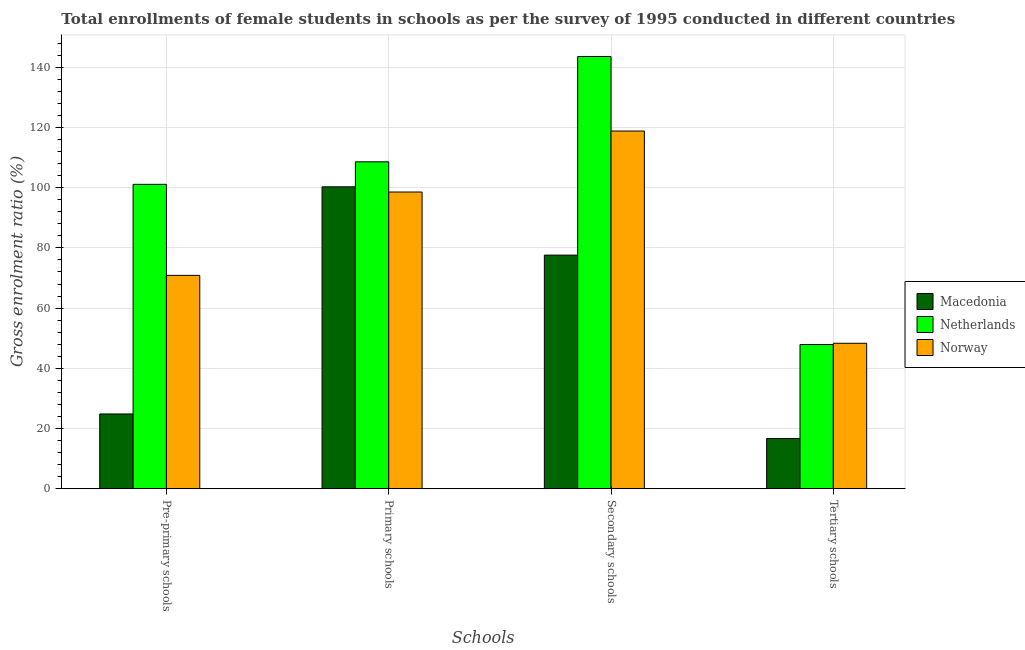How many different coloured bars are there?
Offer a very short reply. 3. How many bars are there on the 3rd tick from the left?
Your answer should be compact. 3. How many bars are there on the 2nd tick from the right?
Give a very brief answer. 3. What is the label of the 4th group of bars from the left?
Offer a very short reply. Tertiary schools. What is the gross enrolment ratio(female) in tertiary schools in Macedonia?
Provide a succinct answer. 16.67. Across all countries, what is the maximum gross enrolment ratio(female) in secondary schools?
Your response must be concise. 143.6. Across all countries, what is the minimum gross enrolment ratio(female) in secondary schools?
Provide a succinct answer. 77.61. In which country was the gross enrolment ratio(female) in tertiary schools minimum?
Make the answer very short. Macedonia. What is the total gross enrolment ratio(female) in pre-primary schools in the graph?
Your answer should be very brief. 196.81. What is the difference between the gross enrolment ratio(female) in tertiary schools in Netherlands and that in Norway?
Keep it short and to the point. -0.42. What is the difference between the gross enrolment ratio(female) in pre-primary schools in Macedonia and the gross enrolment ratio(female) in tertiary schools in Netherlands?
Provide a succinct answer. -23.07. What is the average gross enrolment ratio(female) in primary schools per country?
Provide a short and direct response. 102.49. What is the difference between the gross enrolment ratio(female) in secondary schools and gross enrolment ratio(female) in primary schools in Netherlands?
Provide a succinct answer. 35. What is the ratio of the gross enrolment ratio(female) in tertiary schools in Netherlands to that in Norway?
Provide a short and direct response. 0.99. What is the difference between the highest and the second highest gross enrolment ratio(female) in secondary schools?
Provide a short and direct response. 24.77. What is the difference between the highest and the lowest gross enrolment ratio(female) in pre-primary schools?
Provide a succinct answer. 76.3. Is it the case that in every country, the sum of the gross enrolment ratio(female) in pre-primary schools and gross enrolment ratio(female) in tertiary schools is greater than the sum of gross enrolment ratio(female) in secondary schools and gross enrolment ratio(female) in primary schools?
Provide a short and direct response. No. How many bars are there?
Give a very brief answer. 12. How many countries are there in the graph?
Ensure brevity in your answer.  3. Does the graph contain any zero values?
Your response must be concise. No. Does the graph contain grids?
Your answer should be very brief. Yes. What is the title of the graph?
Give a very brief answer. Total enrollments of female students in schools as per the survey of 1995 conducted in different countries. Does "Guinea-Bissau" appear as one of the legend labels in the graph?
Offer a terse response. No. What is the label or title of the X-axis?
Ensure brevity in your answer.  Schools. What is the Gross enrolment ratio (%) of Macedonia in Pre-primary schools?
Your answer should be very brief. 24.82. What is the Gross enrolment ratio (%) in Netherlands in Pre-primary schools?
Give a very brief answer. 101.12. What is the Gross enrolment ratio (%) in Norway in Pre-primary schools?
Your answer should be compact. 70.87. What is the Gross enrolment ratio (%) of Macedonia in Primary schools?
Keep it short and to the point. 100.29. What is the Gross enrolment ratio (%) in Netherlands in Primary schools?
Your answer should be very brief. 108.6. What is the Gross enrolment ratio (%) of Norway in Primary schools?
Offer a terse response. 98.57. What is the Gross enrolment ratio (%) of Macedonia in Secondary schools?
Keep it short and to the point. 77.61. What is the Gross enrolment ratio (%) of Netherlands in Secondary schools?
Your answer should be compact. 143.6. What is the Gross enrolment ratio (%) of Norway in Secondary schools?
Give a very brief answer. 118.83. What is the Gross enrolment ratio (%) in Macedonia in Tertiary schools?
Keep it short and to the point. 16.67. What is the Gross enrolment ratio (%) of Netherlands in Tertiary schools?
Ensure brevity in your answer.  47.89. What is the Gross enrolment ratio (%) of Norway in Tertiary schools?
Ensure brevity in your answer.  48.31. Across all Schools, what is the maximum Gross enrolment ratio (%) in Macedonia?
Give a very brief answer. 100.29. Across all Schools, what is the maximum Gross enrolment ratio (%) of Netherlands?
Make the answer very short. 143.6. Across all Schools, what is the maximum Gross enrolment ratio (%) in Norway?
Make the answer very short. 118.83. Across all Schools, what is the minimum Gross enrolment ratio (%) in Macedonia?
Offer a terse response. 16.67. Across all Schools, what is the minimum Gross enrolment ratio (%) of Netherlands?
Offer a very short reply. 47.89. Across all Schools, what is the minimum Gross enrolment ratio (%) of Norway?
Provide a succinct answer. 48.31. What is the total Gross enrolment ratio (%) in Macedonia in the graph?
Your answer should be compact. 219.39. What is the total Gross enrolment ratio (%) in Netherlands in the graph?
Keep it short and to the point. 401.21. What is the total Gross enrolment ratio (%) in Norway in the graph?
Give a very brief answer. 336.58. What is the difference between the Gross enrolment ratio (%) in Macedonia in Pre-primary schools and that in Primary schools?
Offer a very short reply. -75.47. What is the difference between the Gross enrolment ratio (%) in Netherlands in Pre-primary schools and that in Primary schools?
Your response must be concise. -7.48. What is the difference between the Gross enrolment ratio (%) of Norway in Pre-primary schools and that in Primary schools?
Make the answer very short. -27.69. What is the difference between the Gross enrolment ratio (%) in Macedonia in Pre-primary schools and that in Secondary schools?
Keep it short and to the point. -52.78. What is the difference between the Gross enrolment ratio (%) of Netherlands in Pre-primary schools and that in Secondary schools?
Keep it short and to the point. -42.48. What is the difference between the Gross enrolment ratio (%) in Norway in Pre-primary schools and that in Secondary schools?
Offer a terse response. -47.95. What is the difference between the Gross enrolment ratio (%) in Macedonia in Pre-primary schools and that in Tertiary schools?
Ensure brevity in your answer.  8.16. What is the difference between the Gross enrolment ratio (%) in Netherlands in Pre-primary schools and that in Tertiary schools?
Offer a very short reply. 53.23. What is the difference between the Gross enrolment ratio (%) of Norway in Pre-primary schools and that in Tertiary schools?
Ensure brevity in your answer.  22.56. What is the difference between the Gross enrolment ratio (%) of Macedonia in Primary schools and that in Secondary schools?
Make the answer very short. 22.69. What is the difference between the Gross enrolment ratio (%) in Netherlands in Primary schools and that in Secondary schools?
Offer a terse response. -35. What is the difference between the Gross enrolment ratio (%) in Norway in Primary schools and that in Secondary schools?
Provide a succinct answer. -20.26. What is the difference between the Gross enrolment ratio (%) in Macedonia in Primary schools and that in Tertiary schools?
Provide a succinct answer. 83.62. What is the difference between the Gross enrolment ratio (%) in Netherlands in Primary schools and that in Tertiary schools?
Your answer should be compact. 60.71. What is the difference between the Gross enrolment ratio (%) of Norway in Primary schools and that in Tertiary schools?
Keep it short and to the point. 50.25. What is the difference between the Gross enrolment ratio (%) in Macedonia in Secondary schools and that in Tertiary schools?
Offer a terse response. 60.94. What is the difference between the Gross enrolment ratio (%) of Netherlands in Secondary schools and that in Tertiary schools?
Your response must be concise. 95.71. What is the difference between the Gross enrolment ratio (%) of Norway in Secondary schools and that in Tertiary schools?
Give a very brief answer. 70.52. What is the difference between the Gross enrolment ratio (%) in Macedonia in Pre-primary schools and the Gross enrolment ratio (%) in Netherlands in Primary schools?
Offer a very short reply. -83.78. What is the difference between the Gross enrolment ratio (%) of Macedonia in Pre-primary schools and the Gross enrolment ratio (%) of Norway in Primary schools?
Keep it short and to the point. -73.74. What is the difference between the Gross enrolment ratio (%) of Netherlands in Pre-primary schools and the Gross enrolment ratio (%) of Norway in Primary schools?
Offer a terse response. 2.55. What is the difference between the Gross enrolment ratio (%) of Macedonia in Pre-primary schools and the Gross enrolment ratio (%) of Netherlands in Secondary schools?
Offer a very short reply. -118.78. What is the difference between the Gross enrolment ratio (%) of Macedonia in Pre-primary schools and the Gross enrolment ratio (%) of Norway in Secondary schools?
Offer a very short reply. -94. What is the difference between the Gross enrolment ratio (%) in Netherlands in Pre-primary schools and the Gross enrolment ratio (%) in Norway in Secondary schools?
Provide a succinct answer. -17.71. What is the difference between the Gross enrolment ratio (%) of Macedonia in Pre-primary schools and the Gross enrolment ratio (%) of Netherlands in Tertiary schools?
Keep it short and to the point. -23.07. What is the difference between the Gross enrolment ratio (%) of Macedonia in Pre-primary schools and the Gross enrolment ratio (%) of Norway in Tertiary schools?
Make the answer very short. -23.49. What is the difference between the Gross enrolment ratio (%) in Netherlands in Pre-primary schools and the Gross enrolment ratio (%) in Norway in Tertiary schools?
Make the answer very short. 52.81. What is the difference between the Gross enrolment ratio (%) in Macedonia in Primary schools and the Gross enrolment ratio (%) in Netherlands in Secondary schools?
Your answer should be compact. -43.31. What is the difference between the Gross enrolment ratio (%) in Macedonia in Primary schools and the Gross enrolment ratio (%) in Norway in Secondary schools?
Offer a very short reply. -18.54. What is the difference between the Gross enrolment ratio (%) of Netherlands in Primary schools and the Gross enrolment ratio (%) of Norway in Secondary schools?
Make the answer very short. -10.23. What is the difference between the Gross enrolment ratio (%) in Macedonia in Primary schools and the Gross enrolment ratio (%) in Netherlands in Tertiary schools?
Provide a short and direct response. 52.4. What is the difference between the Gross enrolment ratio (%) in Macedonia in Primary schools and the Gross enrolment ratio (%) in Norway in Tertiary schools?
Offer a terse response. 51.98. What is the difference between the Gross enrolment ratio (%) in Netherlands in Primary schools and the Gross enrolment ratio (%) in Norway in Tertiary schools?
Ensure brevity in your answer.  60.29. What is the difference between the Gross enrolment ratio (%) in Macedonia in Secondary schools and the Gross enrolment ratio (%) in Netherlands in Tertiary schools?
Your response must be concise. 29.72. What is the difference between the Gross enrolment ratio (%) of Macedonia in Secondary schools and the Gross enrolment ratio (%) of Norway in Tertiary schools?
Provide a short and direct response. 29.29. What is the difference between the Gross enrolment ratio (%) in Netherlands in Secondary schools and the Gross enrolment ratio (%) in Norway in Tertiary schools?
Provide a short and direct response. 95.29. What is the average Gross enrolment ratio (%) in Macedonia per Schools?
Ensure brevity in your answer.  54.85. What is the average Gross enrolment ratio (%) in Netherlands per Schools?
Keep it short and to the point. 100.3. What is the average Gross enrolment ratio (%) in Norway per Schools?
Give a very brief answer. 84.14. What is the difference between the Gross enrolment ratio (%) in Macedonia and Gross enrolment ratio (%) in Netherlands in Pre-primary schools?
Make the answer very short. -76.3. What is the difference between the Gross enrolment ratio (%) of Macedonia and Gross enrolment ratio (%) of Norway in Pre-primary schools?
Offer a terse response. -46.05. What is the difference between the Gross enrolment ratio (%) in Netherlands and Gross enrolment ratio (%) in Norway in Pre-primary schools?
Keep it short and to the point. 30.25. What is the difference between the Gross enrolment ratio (%) in Macedonia and Gross enrolment ratio (%) in Netherlands in Primary schools?
Give a very brief answer. -8.31. What is the difference between the Gross enrolment ratio (%) of Macedonia and Gross enrolment ratio (%) of Norway in Primary schools?
Offer a very short reply. 1.73. What is the difference between the Gross enrolment ratio (%) in Netherlands and Gross enrolment ratio (%) in Norway in Primary schools?
Provide a succinct answer. 10.03. What is the difference between the Gross enrolment ratio (%) in Macedonia and Gross enrolment ratio (%) in Netherlands in Secondary schools?
Give a very brief answer. -66. What is the difference between the Gross enrolment ratio (%) of Macedonia and Gross enrolment ratio (%) of Norway in Secondary schools?
Keep it short and to the point. -41.22. What is the difference between the Gross enrolment ratio (%) of Netherlands and Gross enrolment ratio (%) of Norway in Secondary schools?
Your answer should be very brief. 24.77. What is the difference between the Gross enrolment ratio (%) in Macedonia and Gross enrolment ratio (%) in Netherlands in Tertiary schools?
Keep it short and to the point. -31.22. What is the difference between the Gross enrolment ratio (%) in Macedonia and Gross enrolment ratio (%) in Norway in Tertiary schools?
Make the answer very short. -31.65. What is the difference between the Gross enrolment ratio (%) of Netherlands and Gross enrolment ratio (%) of Norway in Tertiary schools?
Provide a short and direct response. -0.42. What is the ratio of the Gross enrolment ratio (%) in Macedonia in Pre-primary schools to that in Primary schools?
Your answer should be compact. 0.25. What is the ratio of the Gross enrolment ratio (%) in Netherlands in Pre-primary schools to that in Primary schools?
Ensure brevity in your answer.  0.93. What is the ratio of the Gross enrolment ratio (%) of Norway in Pre-primary schools to that in Primary schools?
Ensure brevity in your answer.  0.72. What is the ratio of the Gross enrolment ratio (%) of Macedonia in Pre-primary schools to that in Secondary schools?
Keep it short and to the point. 0.32. What is the ratio of the Gross enrolment ratio (%) in Netherlands in Pre-primary schools to that in Secondary schools?
Provide a succinct answer. 0.7. What is the ratio of the Gross enrolment ratio (%) of Norway in Pre-primary schools to that in Secondary schools?
Offer a terse response. 0.6. What is the ratio of the Gross enrolment ratio (%) in Macedonia in Pre-primary schools to that in Tertiary schools?
Keep it short and to the point. 1.49. What is the ratio of the Gross enrolment ratio (%) of Netherlands in Pre-primary schools to that in Tertiary schools?
Your answer should be compact. 2.11. What is the ratio of the Gross enrolment ratio (%) in Norway in Pre-primary schools to that in Tertiary schools?
Keep it short and to the point. 1.47. What is the ratio of the Gross enrolment ratio (%) of Macedonia in Primary schools to that in Secondary schools?
Give a very brief answer. 1.29. What is the ratio of the Gross enrolment ratio (%) of Netherlands in Primary schools to that in Secondary schools?
Offer a very short reply. 0.76. What is the ratio of the Gross enrolment ratio (%) of Norway in Primary schools to that in Secondary schools?
Offer a very short reply. 0.83. What is the ratio of the Gross enrolment ratio (%) of Macedonia in Primary schools to that in Tertiary schools?
Keep it short and to the point. 6.02. What is the ratio of the Gross enrolment ratio (%) in Netherlands in Primary schools to that in Tertiary schools?
Provide a short and direct response. 2.27. What is the ratio of the Gross enrolment ratio (%) in Norway in Primary schools to that in Tertiary schools?
Offer a very short reply. 2.04. What is the ratio of the Gross enrolment ratio (%) in Macedonia in Secondary schools to that in Tertiary schools?
Offer a terse response. 4.66. What is the ratio of the Gross enrolment ratio (%) of Netherlands in Secondary schools to that in Tertiary schools?
Offer a terse response. 3. What is the ratio of the Gross enrolment ratio (%) in Norway in Secondary schools to that in Tertiary schools?
Provide a short and direct response. 2.46. What is the difference between the highest and the second highest Gross enrolment ratio (%) of Macedonia?
Offer a very short reply. 22.69. What is the difference between the highest and the second highest Gross enrolment ratio (%) of Netherlands?
Make the answer very short. 35. What is the difference between the highest and the second highest Gross enrolment ratio (%) in Norway?
Offer a terse response. 20.26. What is the difference between the highest and the lowest Gross enrolment ratio (%) in Macedonia?
Make the answer very short. 83.62. What is the difference between the highest and the lowest Gross enrolment ratio (%) in Netherlands?
Provide a succinct answer. 95.71. What is the difference between the highest and the lowest Gross enrolment ratio (%) of Norway?
Offer a terse response. 70.52. 